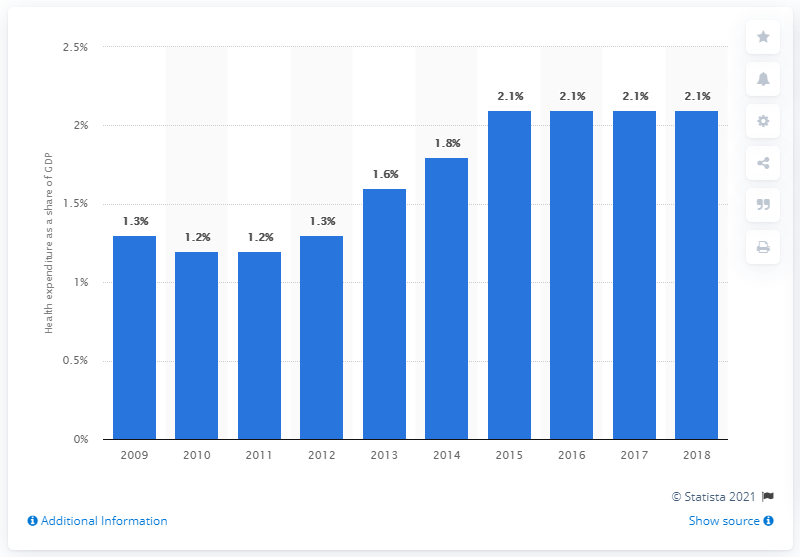Indicate a few pertinent items in this graphic. In the financial year 2018, the health expenditure in Singapore accounted for 2.1% of the country's gross domestic product. 